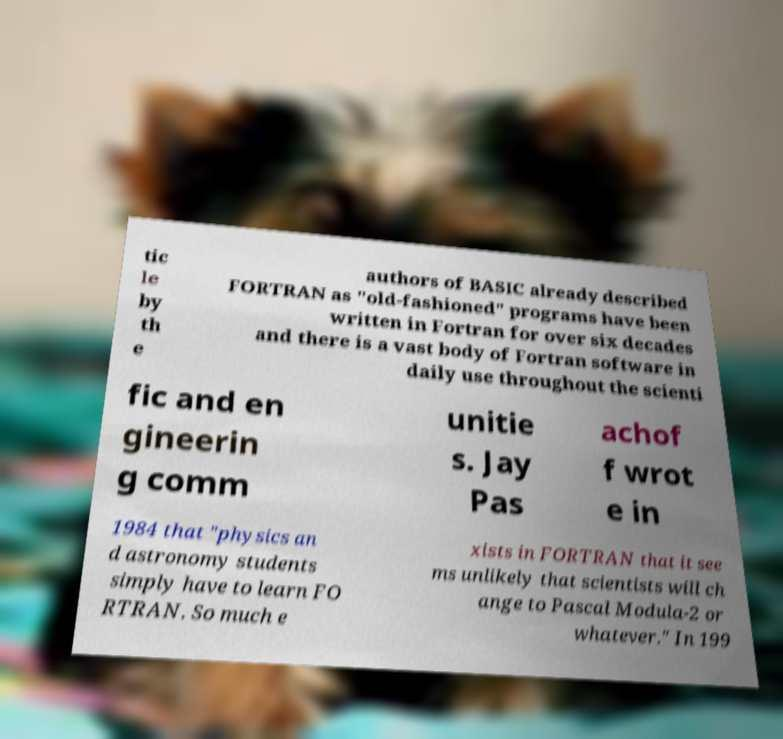I need the written content from this picture converted into text. Can you do that? tic le by th e authors of BASIC already described FORTRAN as "old-fashioned" programs have been written in Fortran for over six decades and there is a vast body of Fortran software in daily use throughout the scienti fic and en gineerin g comm unitie s. Jay Pas achof f wrot e in 1984 that "physics an d astronomy students simply have to learn FO RTRAN. So much e xists in FORTRAN that it see ms unlikely that scientists will ch ange to Pascal Modula-2 or whatever." In 199 